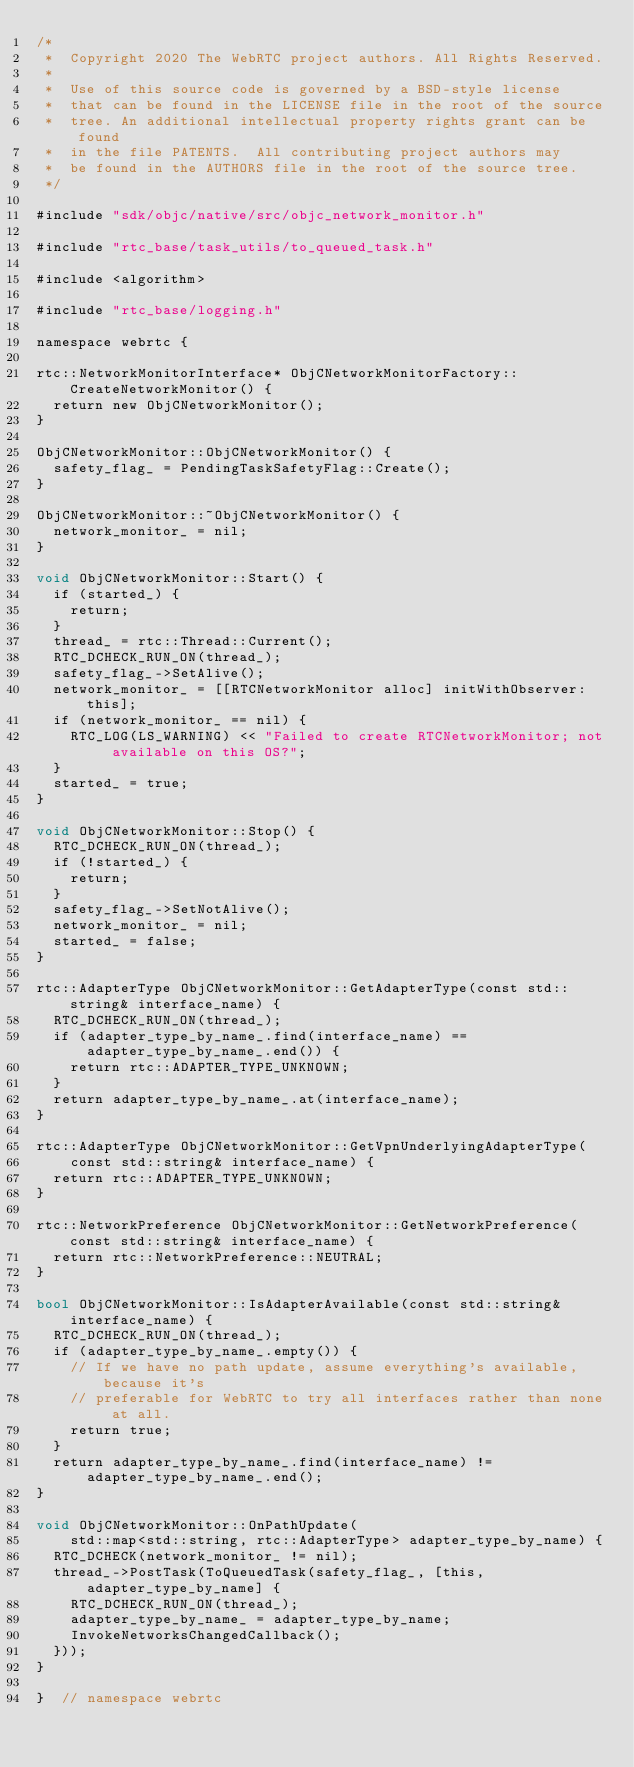Convert code to text. <code><loc_0><loc_0><loc_500><loc_500><_ObjectiveC_>/*
 *  Copyright 2020 The WebRTC project authors. All Rights Reserved.
 *
 *  Use of this source code is governed by a BSD-style license
 *  that can be found in the LICENSE file in the root of the source
 *  tree. An additional intellectual property rights grant can be found
 *  in the file PATENTS.  All contributing project authors may
 *  be found in the AUTHORS file in the root of the source tree.
 */

#include "sdk/objc/native/src/objc_network_monitor.h"

#include "rtc_base/task_utils/to_queued_task.h"

#include <algorithm>

#include "rtc_base/logging.h"

namespace webrtc {

rtc::NetworkMonitorInterface* ObjCNetworkMonitorFactory::CreateNetworkMonitor() {
  return new ObjCNetworkMonitor();
}

ObjCNetworkMonitor::ObjCNetworkMonitor() {
  safety_flag_ = PendingTaskSafetyFlag::Create();
}

ObjCNetworkMonitor::~ObjCNetworkMonitor() {
  network_monitor_ = nil;
}

void ObjCNetworkMonitor::Start() {
  if (started_) {
    return;
  }
  thread_ = rtc::Thread::Current();
  RTC_DCHECK_RUN_ON(thread_);
  safety_flag_->SetAlive();
  network_monitor_ = [[RTCNetworkMonitor alloc] initWithObserver:this];
  if (network_monitor_ == nil) {
    RTC_LOG(LS_WARNING) << "Failed to create RTCNetworkMonitor; not available on this OS?";
  }
  started_ = true;
}

void ObjCNetworkMonitor::Stop() {
  RTC_DCHECK_RUN_ON(thread_);
  if (!started_) {
    return;
  }
  safety_flag_->SetNotAlive();
  network_monitor_ = nil;
  started_ = false;
}

rtc::AdapterType ObjCNetworkMonitor::GetAdapterType(const std::string& interface_name) {
  RTC_DCHECK_RUN_ON(thread_);
  if (adapter_type_by_name_.find(interface_name) == adapter_type_by_name_.end()) {
    return rtc::ADAPTER_TYPE_UNKNOWN;
  }
  return adapter_type_by_name_.at(interface_name);
}

rtc::AdapterType ObjCNetworkMonitor::GetVpnUnderlyingAdapterType(
    const std::string& interface_name) {
  return rtc::ADAPTER_TYPE_UNKNOWN;
}

rtc::NetworkPreference ObjCNetworkMonitor::GetNetworkPreference(const std::string& interface_name) {
  return rtc::NetworkPreference::NEUTRAL;
}

bool ObjCNetworkMonitor::IsAdapterAvailable(const std::string& interface_name) {
  RTC_DCHECK_RUN_ON(thread_);
  if (adapter_type_by_name_.empty()) {
    // If we have no path update, assume everything's available, because it's
    // preferable for WebRTC to try all interfaces rather than none at all.
    return true;
  }
  return adapter_type_by_name_.find(interface_name) != adapter_type_by_name_.end();
}

void ObjCNetworkMonitor::OnPathUpdate(
    std::map<std::string, rtc::AdapterType> adapter_type_by_name) {
  RTC_DCHECK(network_monitor_ != nil);
  thread_->PostTask(ToQueuedTask(safety_flag_, [this, adapter_type_by_name] {
    RTC_DCHECK_RUN_ON(thread_);
    adapter_type_by_name_ = adapter_type_by_name;
    InvokeNetworksChangedCallback();
  }));
}

}  // namespace webrtc
</code> 